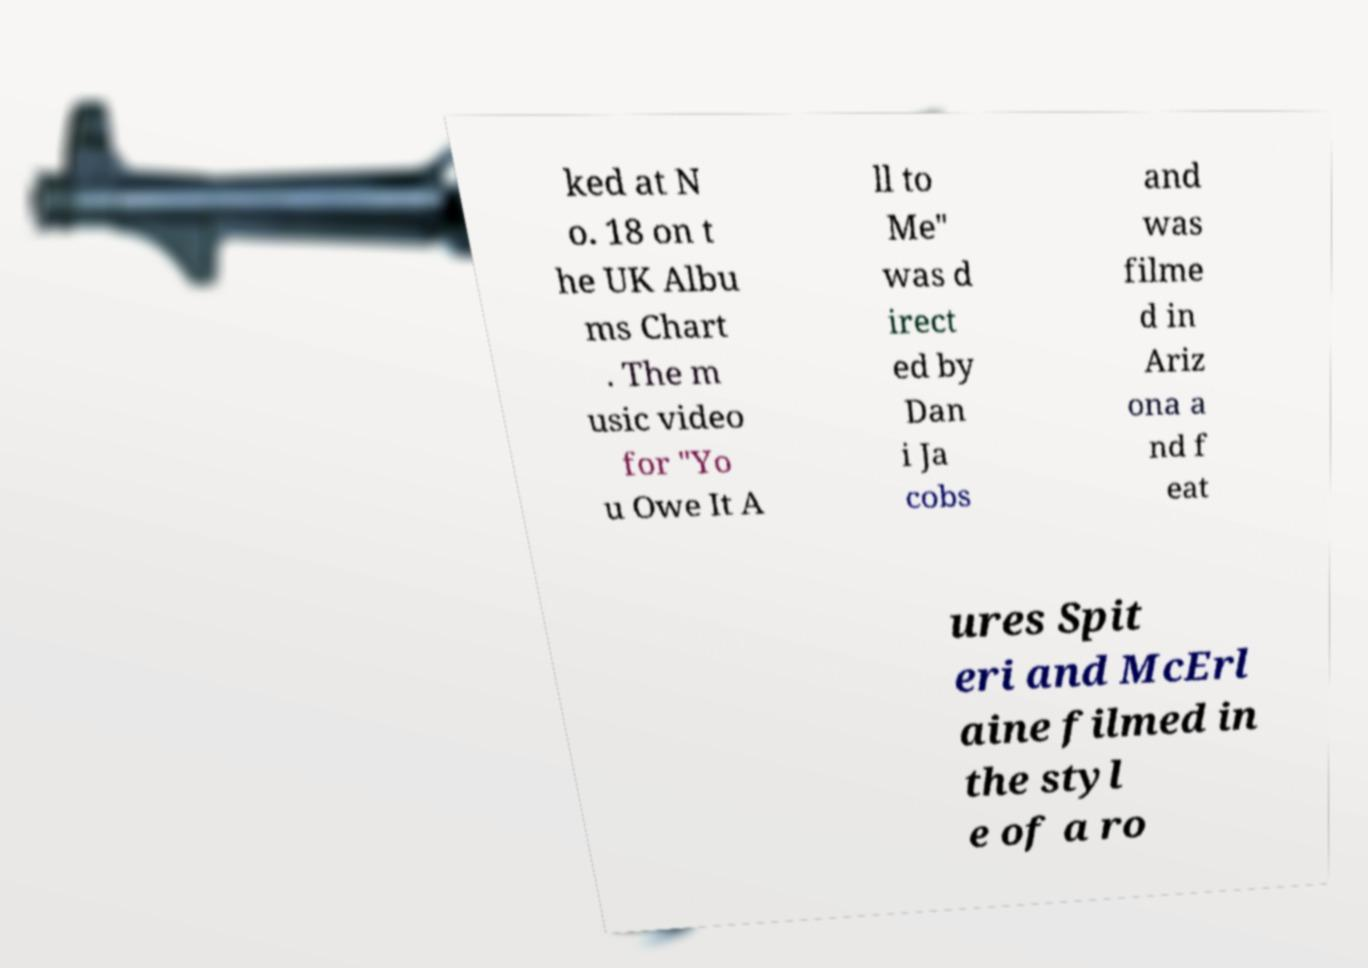Please identify and transcribe the text found in this image. ked at N o. 18 on t he UK Albu ms Chart . The m usic video for "Yo u Owe It A ll to Me" was d irect ed by Dan i Ja cobs and was filme d in Ariz ona a nd f eat ures Spit eri and McErl aine filmed in the styl e of a ro 